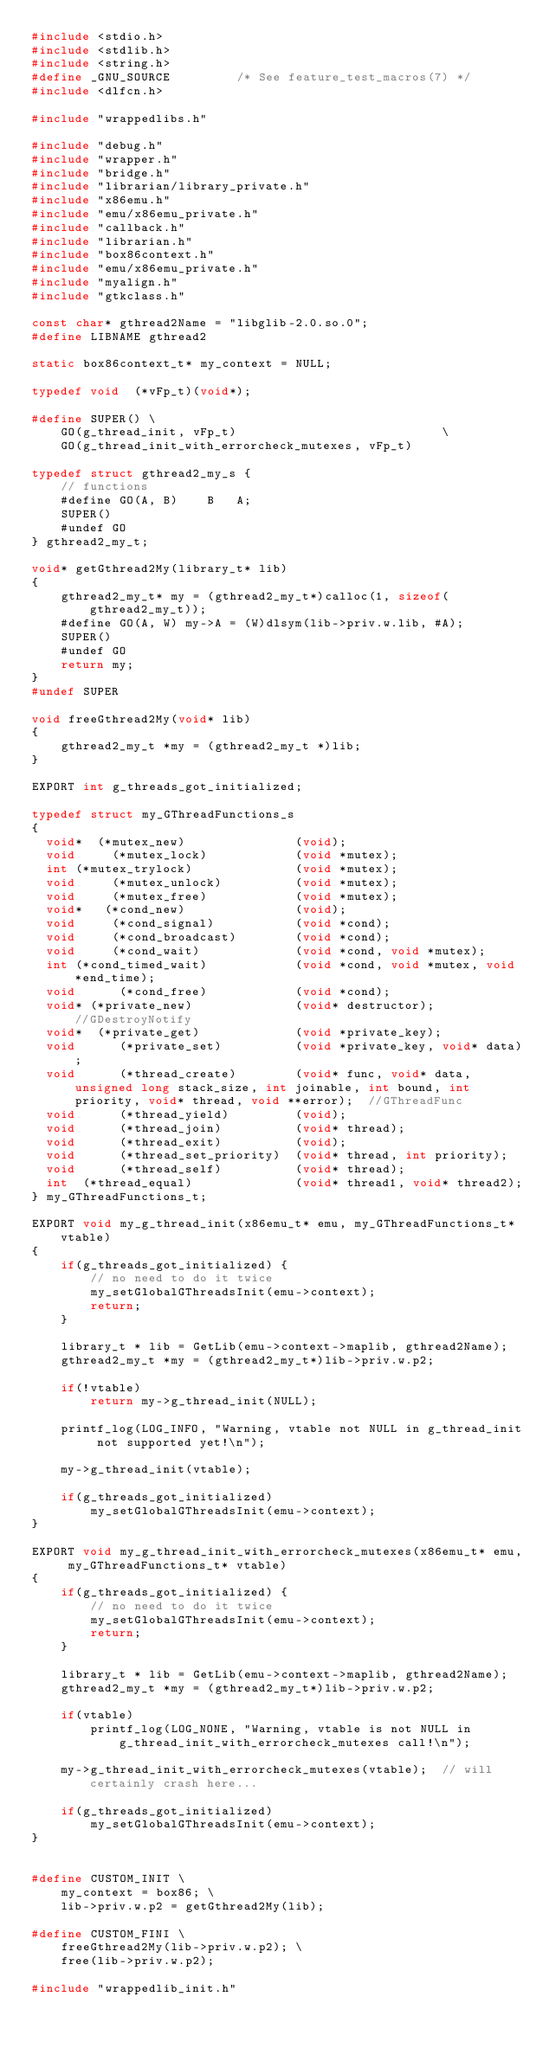Convert code to text. <code><loc_0><loc_0><loc_500><loc_500><_C_>#include <stdio.h>
#include <stdlib.h>
#include <string.h>
#define _GNU_SOURCE         /* See feature_test_macros(7) */
#include <dlfcn.h>

#include "wrappedlibs.h"

#include "debug.h"
#include "wrapper.h"
#include "bridge.h"
#include "librarian/library_private.h"
#include "x86emu.h"
#include "emu/x86emu_private.h"
#include "callback.h"
#include "librarian.h"
#include "box86context.h"
#include "emu/x86emu_private.h"
#include "myalign.h"
#include "gtkclass.h"

const char* gthread2Name = "libglib-2.0.so.0";
#define LIBNAME gthread2

static box86context_t* my_context = NULL;

typedef void  (*vFp_t)(void*);

#define SUPER() \
    GO(g_thread_init, vFp_t)                            \
    GO(g_thread_init_with_errorcheck_mutexes, vFp_t)

typedef struct gthread2_my_s {
    // functions
    #define GO(A, B)    B   A;
    SUPER()
    #undef GO
} gthread2_my_t;

void* getGthread2My(library_t* lib)
{
    gthread2_my_t* my = (gthread2_my_t*)calloc(1, sizeof(gthread2_my_t));
    #define GO(A, W) my->A = (W)dlsym(lib->priv.w.lib, #A);
    SUPER()
    #undef GO
    return my;
}
#undef SUPER

void freeGthread2My(void* lib)
{
    gthread2_my_t *my = (gthread2_my_t *)lib;
}

EXPORT int g_threads_got_initialized;

typedef struct my_GThreadFunctions_s
{
  void*  (*mutex_new)               (void);
  void     (*mutex_lock)            (void *mutex);
  int (*mutex_trylock)              (void *mutex);
  void     (*mutex_unlock)          (void *mutex);
  void     (*mutex_free)            (void *mutex);
  void*   (*cond_new)               (void);
  void     (*cond_signal)           (void *cond);
  void     (*cond_broadcast)        (void *cond);
  void     (*cond_wait)             (void *cond, void *mutex);
  int (*cond_timed_wait)            (void *cond, void *mutex, void *end_time);
  void      (*cond_free)            (void *cond);
  void* (*private_new)              (void* destructor);            //GDestroyNotify
  void*  (*private_get)             (void *private_key);
  void      (*private_set)          (void *private_key, void* data);
  void      (*thread_create)        (void* func, void* data, unsigned long stack_size, int joinable, int bound, int priority, void* thread, void **error);  //GThreadFunc
  void      (*thread_yield)         (void);
  void      (*thread_join)          (void* thread);
  void      (*thread_exit)          (void);
  void      (*thread_set_priority)  (void* thread, int priority);
  void      (*thread_self)          (void* thread);
  int  (*thread_equal)              (void* thread1, void* thread2);
} my_GThreadFunctions_t;

EXPORT void my_g_thread_init(x86emu_t* emu, my_GThreadFunctions_t* vtable)
{
    if(g_threads_got_initialized) {
        // no need to do it twice
        my_setGlobalGThreadsInit(emu->context);
        return;
    }

    library_t * lib = GetLib(emu->context->maplib, gthread2Name);
    gthread2_my_t *my = (gthread2_my_t*)lib->priv.w.p2;

    if(!vtable)
        return my->g_thread_init(NULL);

    printf_log(LOG_INFO, "Warning, vtable not NULL in g_thread_init not supported yet!\n");
    
    my->g_thread_init(vtable);

    if(g_threads_got_initialized)
        my_setGlobalGThreadsInit(emu->context);
}

EXPORT void my_g_thread_init_with_errorcheck_mutexes(x86emu_t* emu, my_GThreadFunctions_t* vtable)
{
    if(g_threads_got_initialized) {
        // no need to do it twice
        my_setGlobalGThreadsInit(emu->context);
        return;
    }

    library_t * lib = GetLib(emu->context->maplib, gthread2Name);
    gthread2_my_t *my = (gthread2_my_t*)lib->priv.w.p2;

    if(vtable)
        printf_log(LOG_NONE, "Warning, vtable is not NULL in g_thread_init_with_errorcheck_mutexes call!\n");
    
    my->g_thread_init_with_errorcheck_mutexes(vtable);  // will certainly crash here...

    if(g_threads_got_initialized)
        my_setGlobalGThreadsInit(emu->context);
}


#define CUSTOM_INIT \
    my_context = box86; \
    lib->priv.w.p2 = getGthread2My(lib);

#define CUSTOM_FINI \
    freeGthread2My(lib->priv.w.p2); \
    free(lib->priv.w.p2);

#include "wrappedlib_init.h"

</code> 